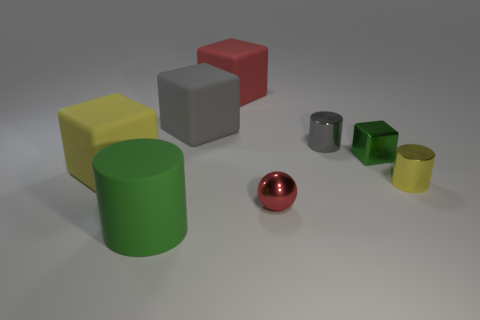Is there a tiny green thing made of the same material as the red ball?
Ensure brevity in your answer.  Yes. How many small cubes are there?
Make the answer very short. 1. Do the tiny green cube and the green object in front of the yellow matte object have the same material?
Your answer should be compact. No. There is a thing that is the same color as the tiny cube; what is it made of?
Offer a terse response. Rubber. What number of balls are the same color as the shiny cube?
Offer a very short reply. 0. What size is the green shiny thing?
Offer a very short reply. Small. Is the shape of the big gray thing the same as the green object left of the red metal sphere?
Offer a terse response. No. What is the color of the other tiny cylinder that is the same material as the yellow cylinder?
Provide a succinct answer. Gray. How big is the metal object in front of the yellow metallic thing?
Make the answer very short. Small. Are there fewer tiny yellow things in front of the red matte thing than gray things?
Offer a terse response. Yes. 